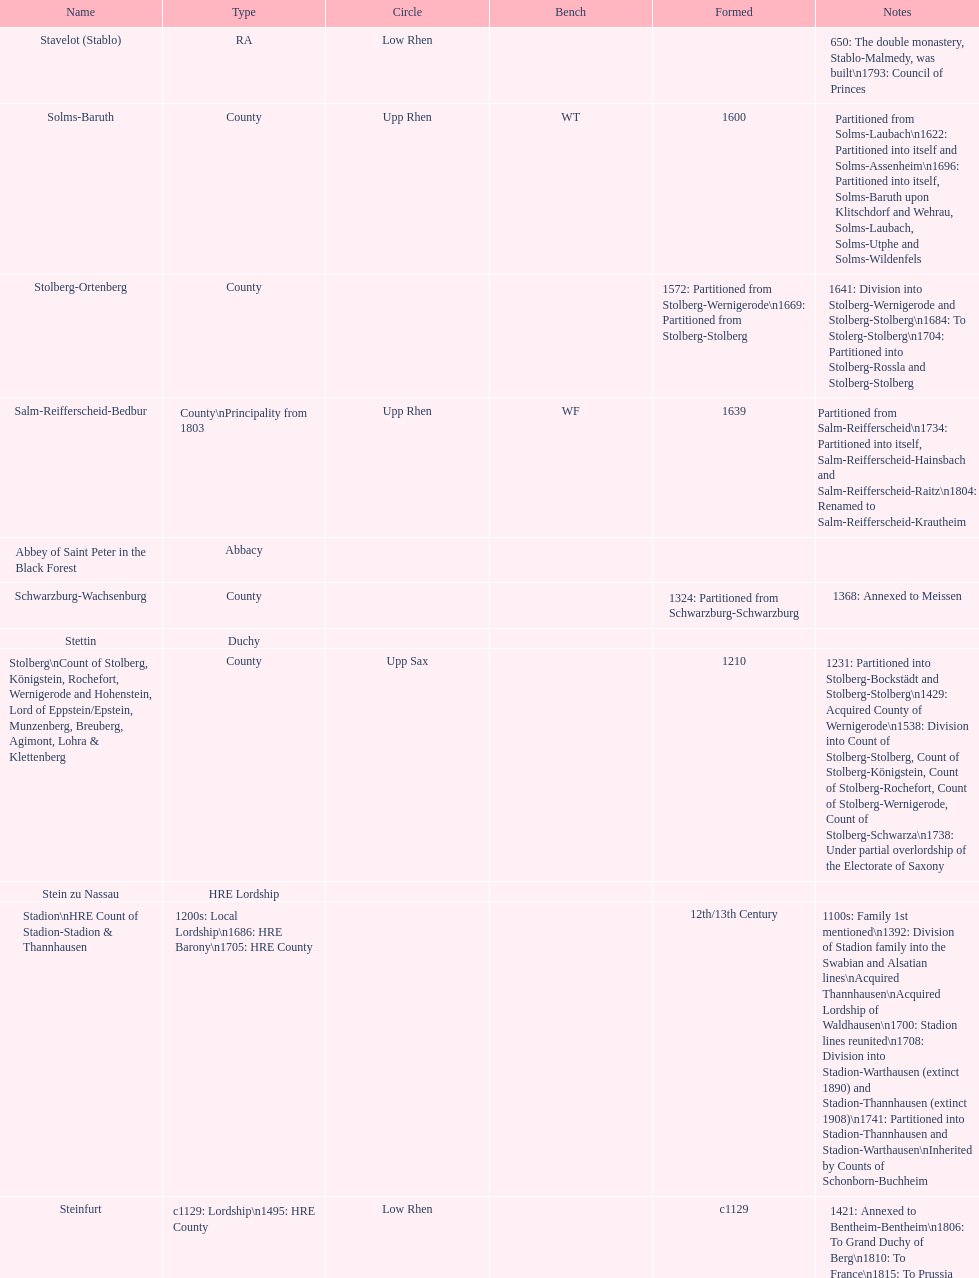How many states were of the same type as stuhlingen? 3. 